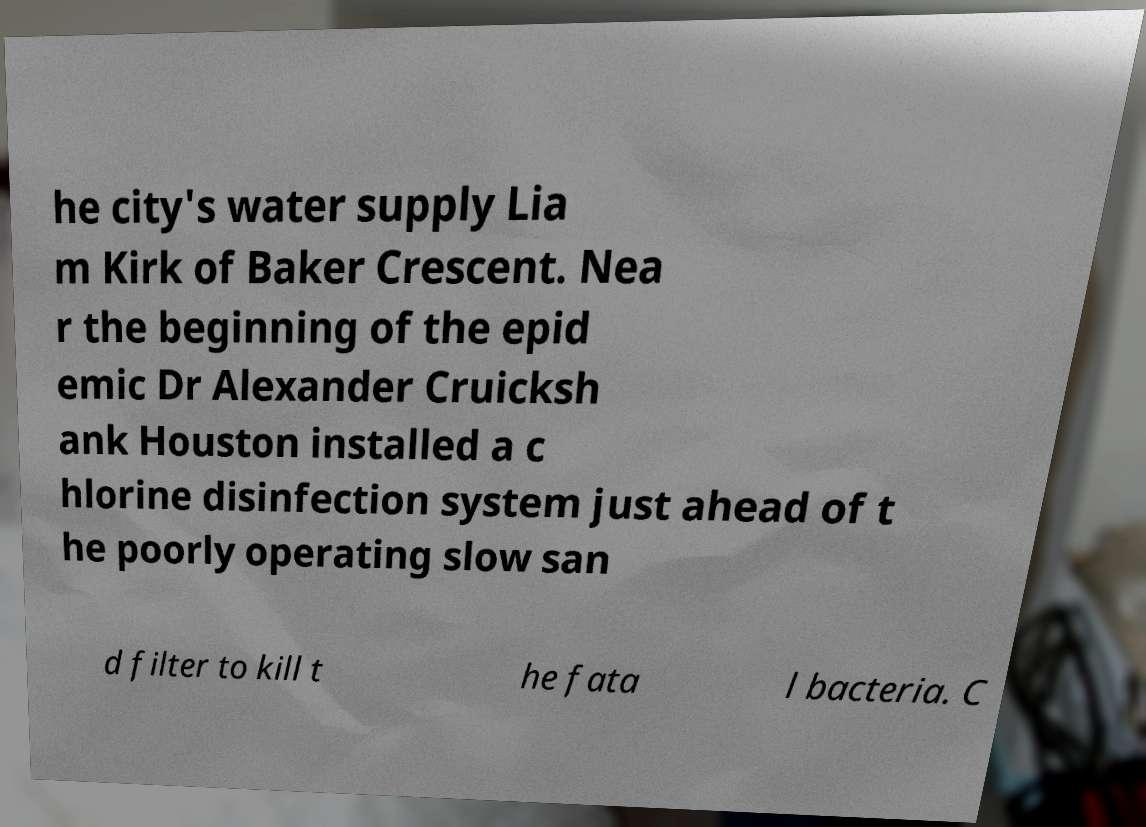For documentation purposes, I need the text within this image transcribed. Could you provide that? he city's water supply Lia m Kirk of Baker Crescent. Nea r the beginning of the epid emic Dr Alexander Cruicksh ank Houston installed a c hlorine disinfection system just ahead of t he poorly operating slow san d filter to kill t he fata l bacteria. C 